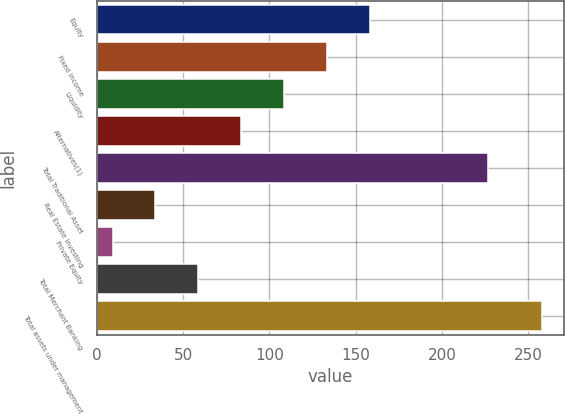Convert chart. <chart><loc_0><loc_0><loc_500><loc_500><bar_chart><fcel>Equity<fcel>Fixed income<fcel>Liquidity<fcel>Alternatives(1)<fcel>Total Traditional Asset<fcel>Real Estate Investing<fcel>Private Equity<fcel>Total Merchant Banking<fcel>Total assets under management<nl><fcel>158.4<fcel>133.5<fcel>108.6<fcel>83.7<fcel>227<fcel>33.9<fcel>9<fcel>58.8<fcel>258<nl></chart> 